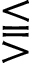<formula> <loc_0><loc_0><loc_500><loc_500>\leq s s e q q g t r</formula> 